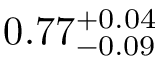Convert formula to latex. <formula><loc_0><loc_0><loc_500><loc_500>0 . 7 7 _ { - 0 . 0 9 } ^ { + 0 . 0 4 }</formula> 